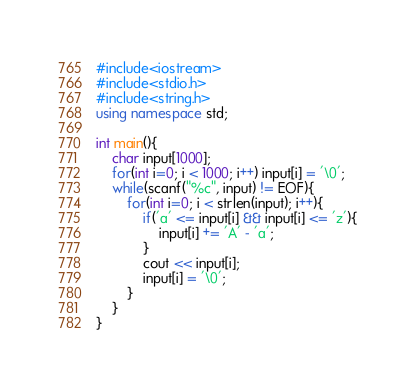Convert code to text. <code><loc_0><loc_0><loc_500><loc_500><_C++_>#include<iostream>
#include<stdio.h>
#include<string.h>
using namespace std;

int main(){
	char input[1000];
	for(int i=0; i < 1000; i++) input[i] = '\0';
	while(scanf("%c", input) != EOF){
		for(int i=0; i < strlen(input); i++){
			if('a' <= input[i] && input[i] <= 'z'){
				input[i] += 'A' - 'a';
			}
			cout << input[i];
			input[i] = '\0';
		}
	}
}</code> 